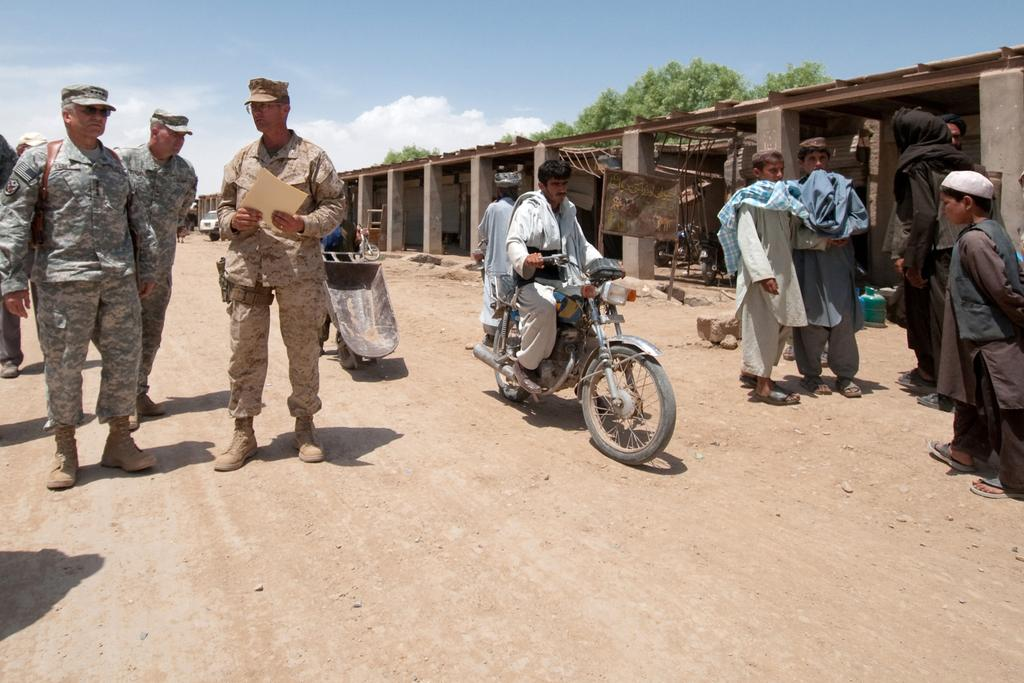What are the people in the image doing? The people in the image are standing on the road. What vehicle can be seen in the image? There is a man riding a motorcycle in the image. What other type of vehicle is present in the image? There is a car in the image. What can be seen in the background of the image? There is a tree in the image. How would you describe the sky in the image? The sky is blue and cloudy in the image. What type of chalk is being used by the authority figure in the image? There is no authority figure or chalk present in the image. What color is the silver object in the image? There is no silver object present in the image. 